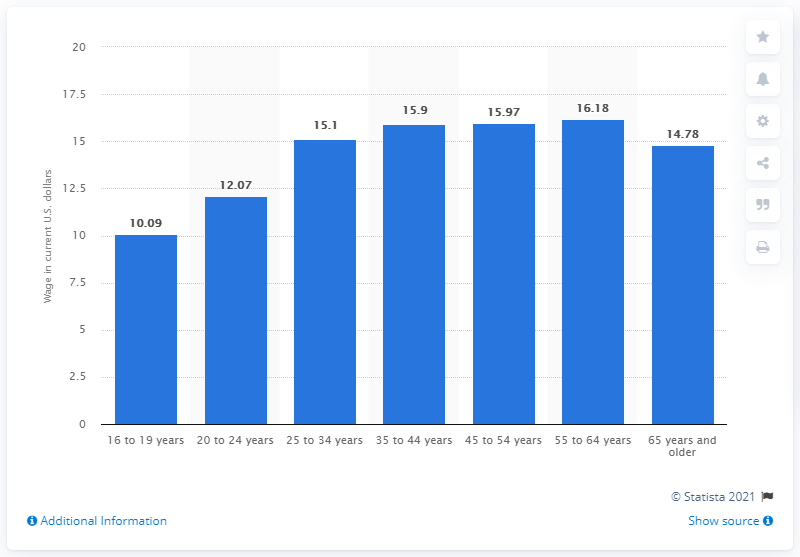Mention a couple of crucial points in this snapshot. According to data from 2019, the average hourly rate for female wage workers between the ages of 20 and 24 was $12.07 per hour. 